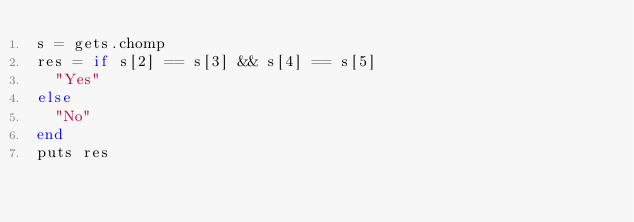<code> <loc_0><loc_0><loc_500><loc_500><_Ruby_>s = gets.chomp
res = if s[2] == s[3] && s[4] == s[5]
  "Yes"
else
  "No"
end
puts res</code> 